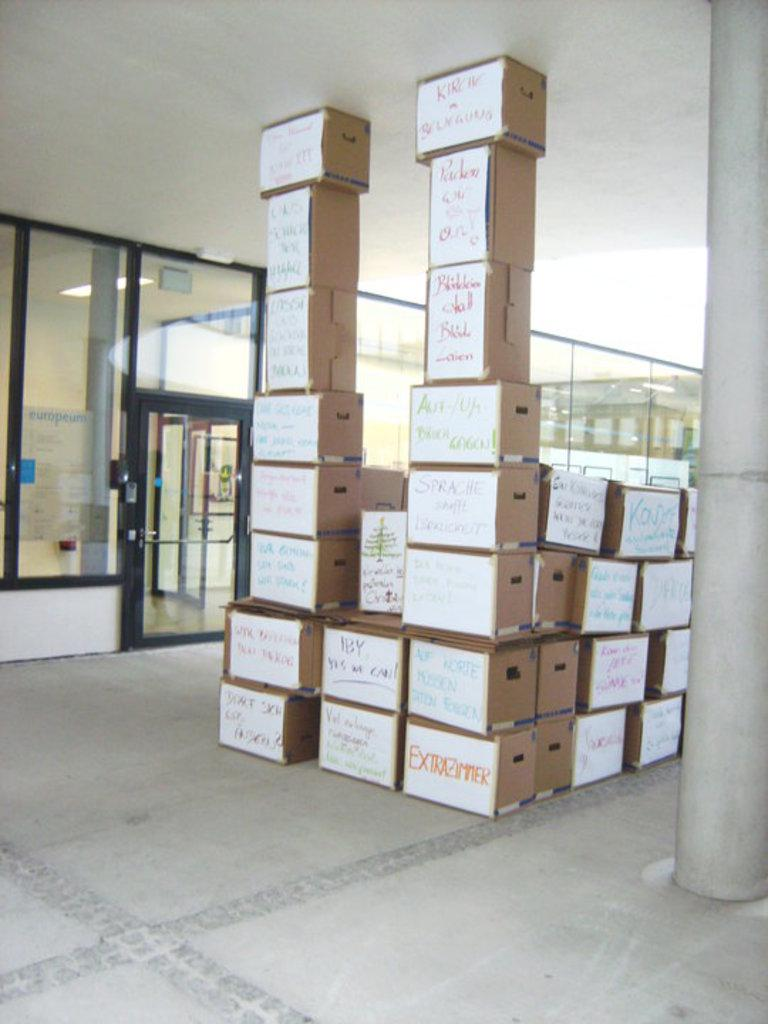<image>
Relay a brief, clear account of the picture shown. A box labeled Extrazimmer is at the bottom of a stack of boxes. 